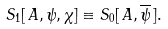Convert formula to latex. <formula><loc_0><loc_0><loc_500><loc_500>S _ { 1 } [ \, A , \psi , \chi ] \equiv S _ { 0 } [ \, A , \overline { \psi } \, ] .</formula> 